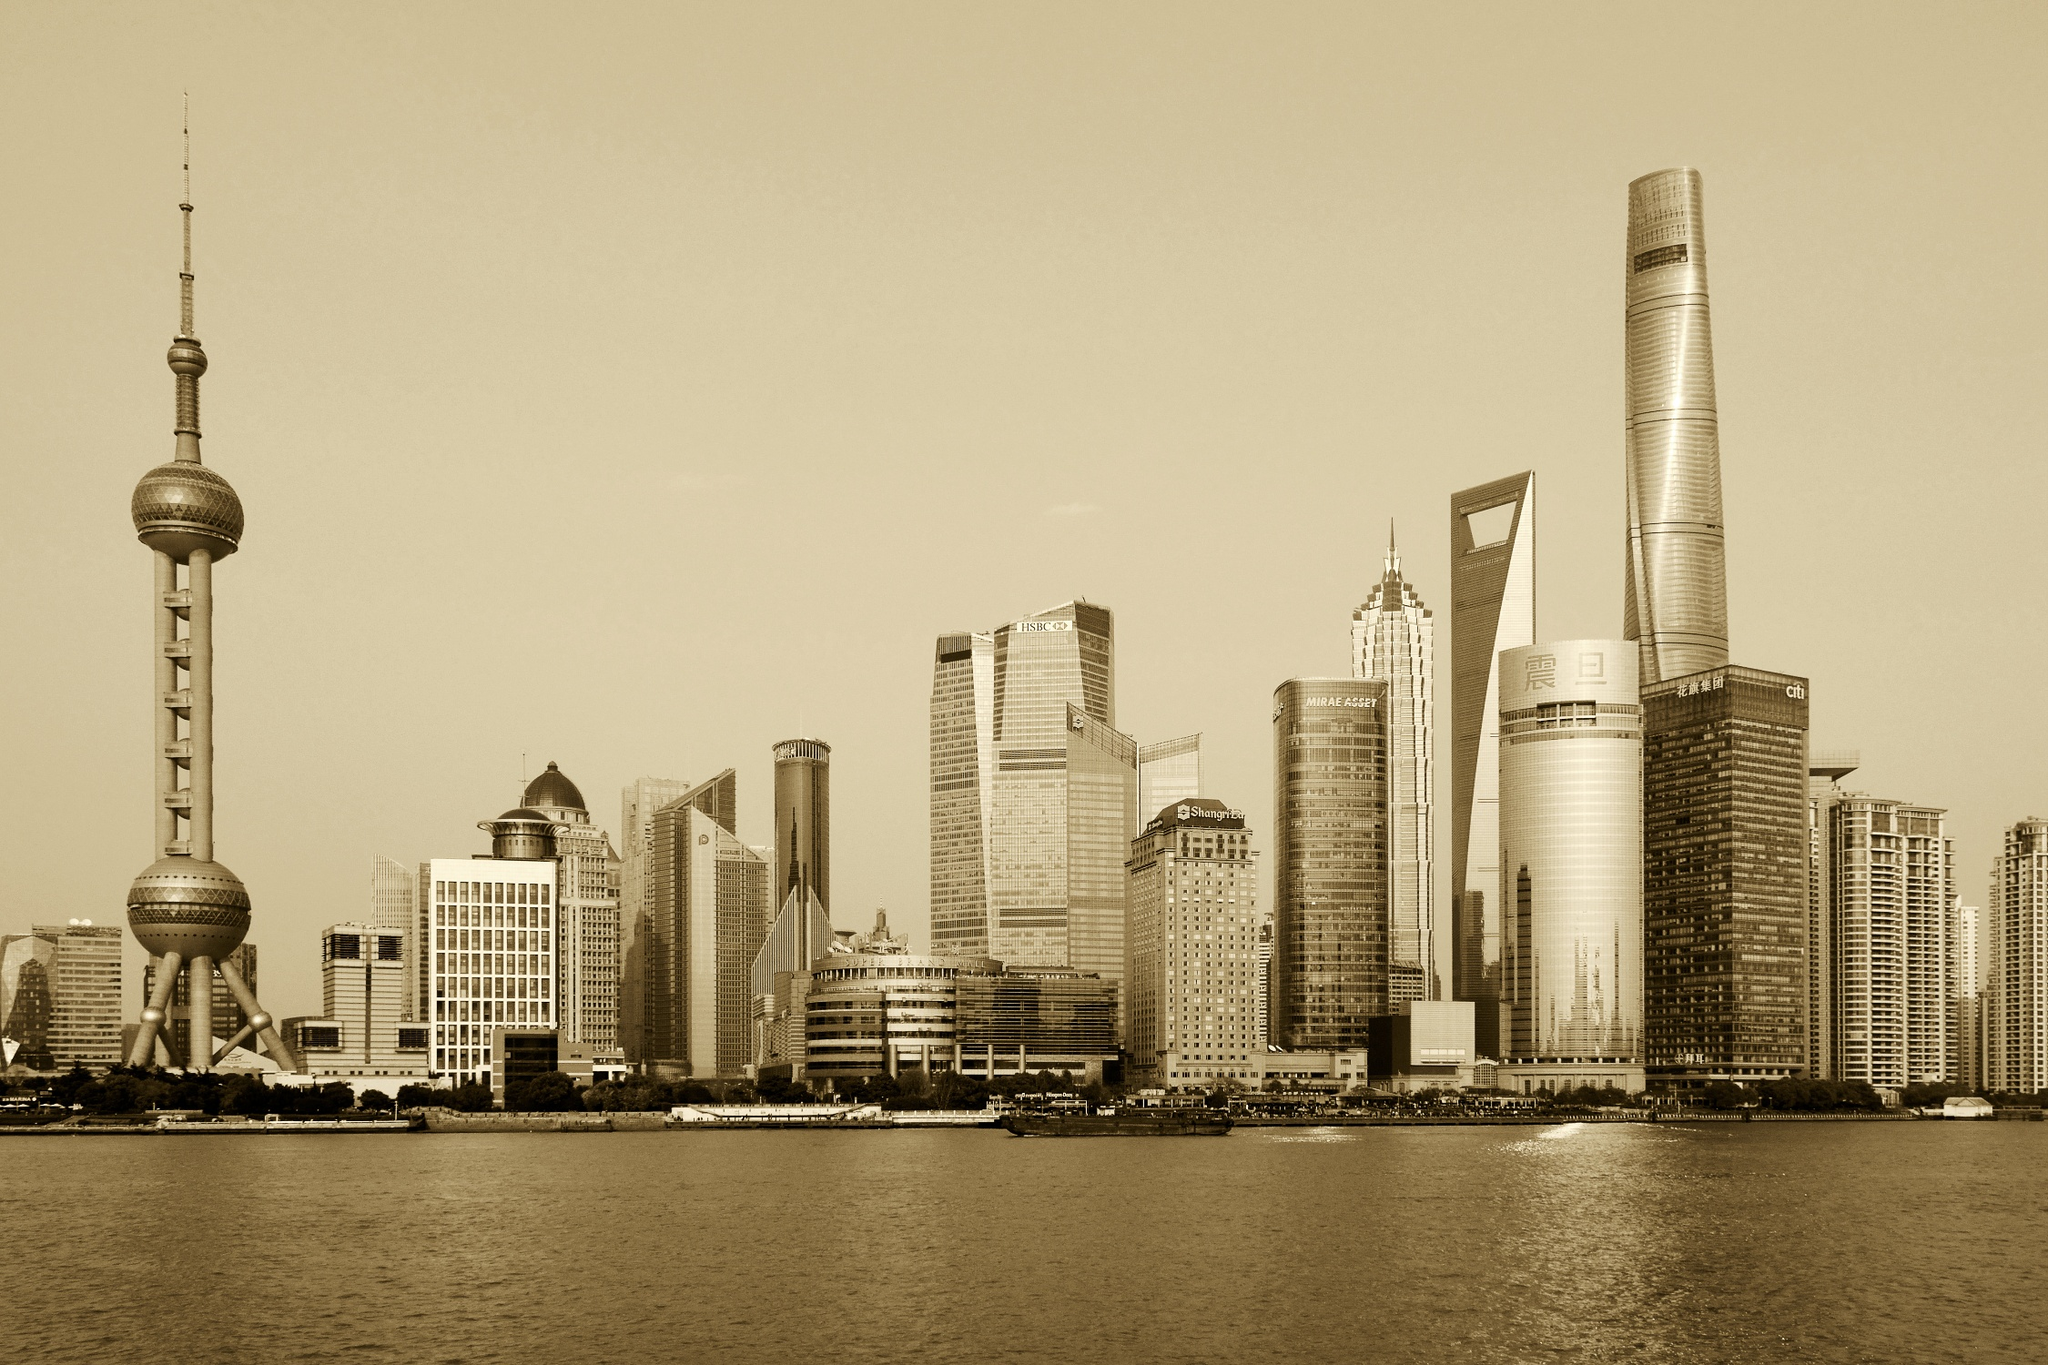Imagine the buildings had a conversation, what might they talk about? In a whimsical scenario where the buildings could converse, the Oriental Pearl Tower might reminisce about the older days, enlightening the younger skyscrapers with tales of Shanghai’s rapid transformation. The Jin Mao Tower could share its experiences of being an architectural marvel, drawing people from around the world to marvel at its design. The Shanghai World Financial Center might discuss the complexities and excitement of international business and its observations of the global economy. The Shanghai Tower could excitedly talk about the innovations in sustainable technology and futuristic designs that make it a symbol of the future. Together, they would discuss their collective contribution to making Shanghai a dynamic, ever-evolving metropolis, while the calm waters of the Huangpu River would reflect their animated exchanges, silently appreciating their stories.  How might changes in climate affect this skyline in the future? The skyline of Shanghai, like many other coastal cities, faces potential risks due to climate change. Rising sea levels could threaten lower parts of the city, putting immense pressure on existing infrastructure. Buildings like the Shanghai Tower, which incorporate advanced sustainability features, set a precedent for future architectural designs that need to prioritize resilience and adaptability. Increased temperatures might demand more efficient cooling systems within these skyscrapers, while potential increases in severe weather events could necessitate stronger, more durable construction methods. Urban planning will likely evolve, with a greater emphasis on green spaces, water management systems, and renewable energy sources to mitigate the impacts of climate change. The skyline will continue to stand as a symbol of progress, adapting and evolving with the changing environment to ensure the safety and longevity of its iconic structures. 